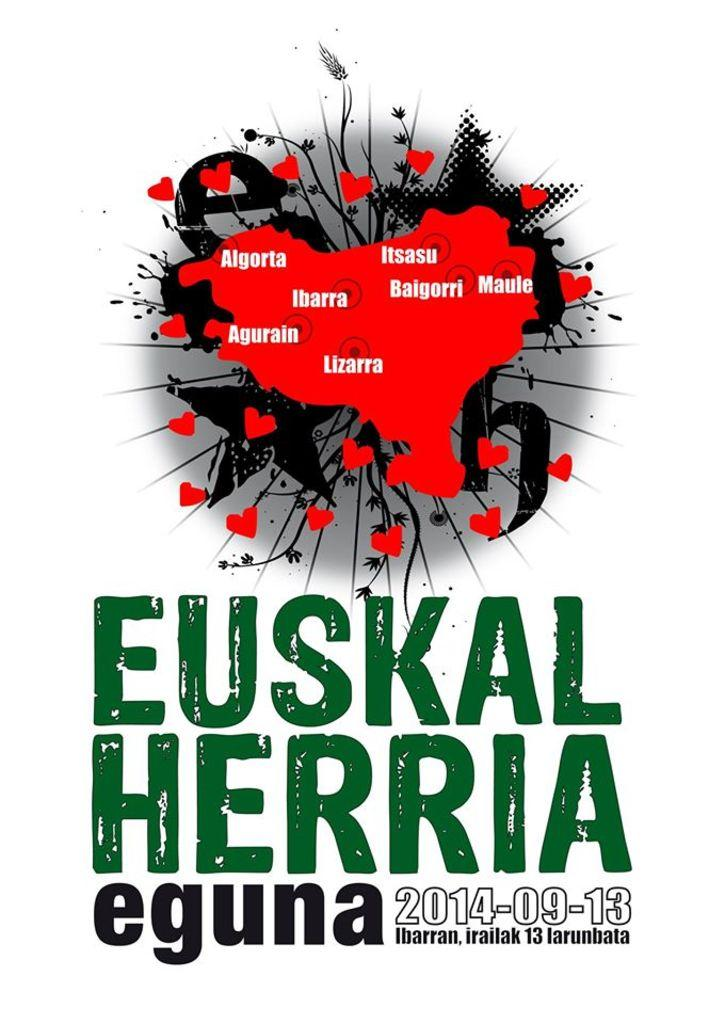<image>
Share a concise interpretation of the image provided. A poster for an event called Euskal Herria eguna is displayed 